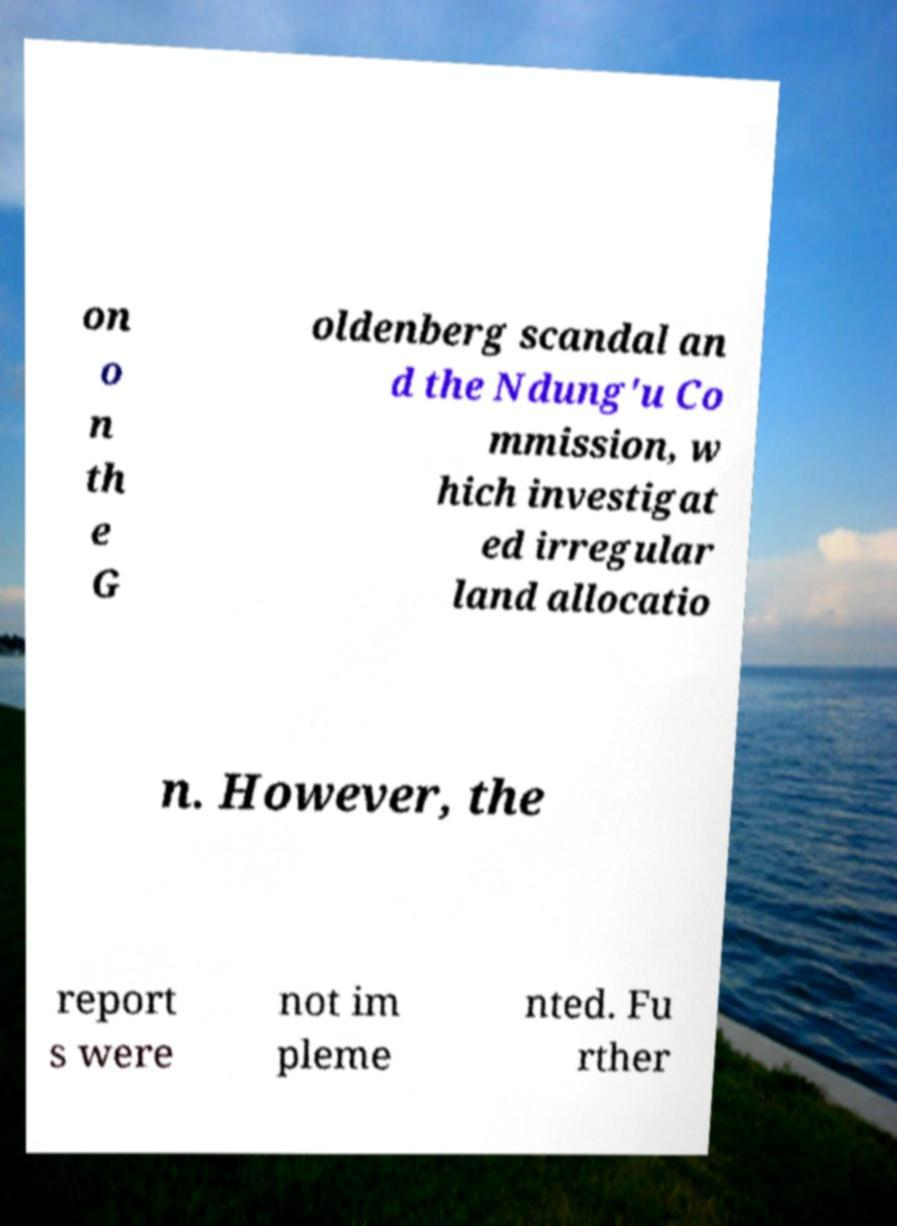What messages or text are displayed in this image? I need them in a readable, typed format. on o n th e G oldenberg scandal an d the Ndung'u Co mmission, w hich investigat ed irregular land allocatio n. However, the report s were not im pleme nted. Fu rther 